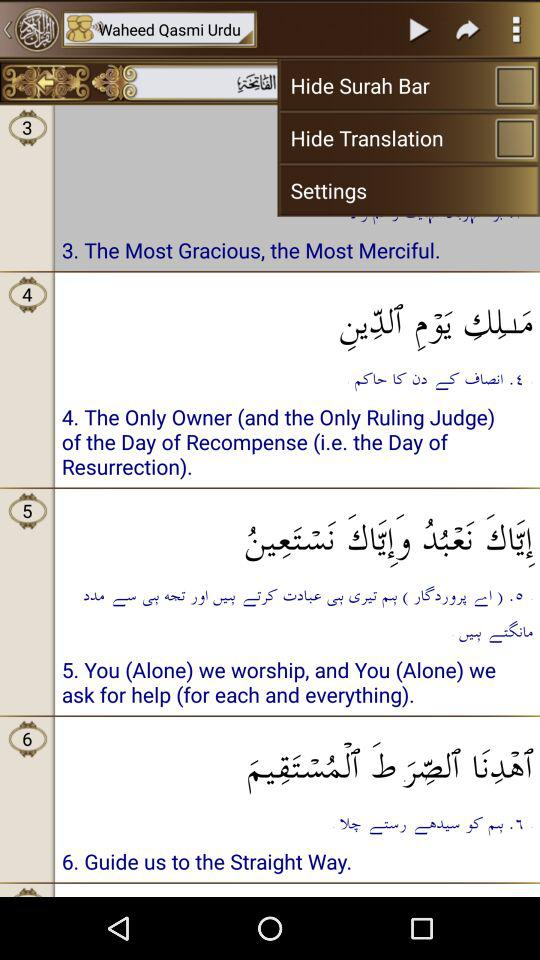What is the status of "Hide Translation"? The status is off. 